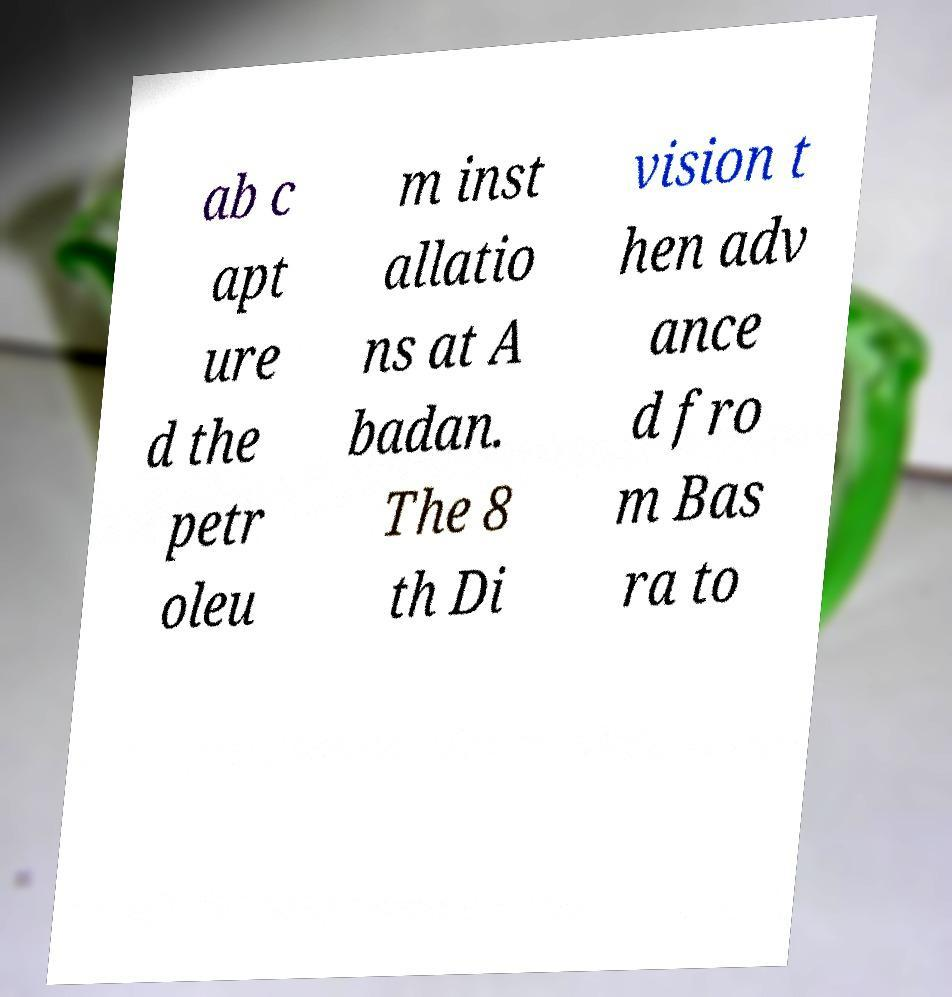Can you read and provide the text displayed in the image?This photo seems to have some interesting text. Can you extract and type it out for me? ab c apt ure d the petr oleu m inst allatio ns at A badan. The 8 th Di vision t hen adv ance d fro m Bas ra to 